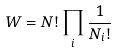<formula> <loc_0><loc_0><loc_500><loc_500>W = N ! \prod _ { i } \frac { 1 } { N _ { i } ! }</formula> 